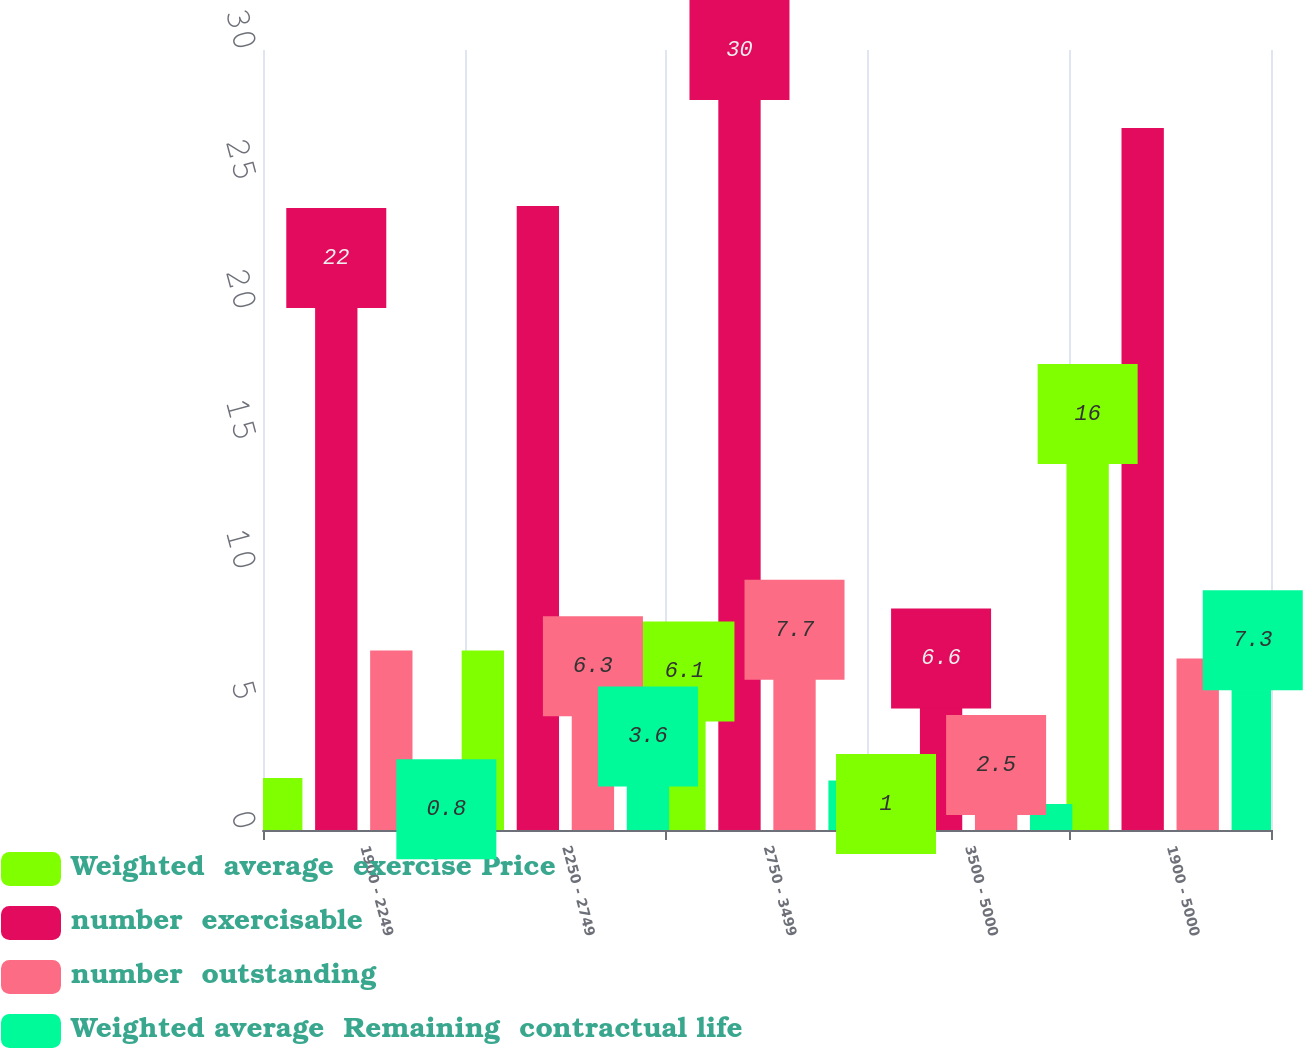Convert chart to OTSL. <chart><loc_0><loc_0><loc_500><loc_500><stacked_bar_chart><ecel><fcel>1900 - 2249<fcel>2250 - 2749<fcel>2750 - 3499<fcel>3500 - 5000<fcel>1900 - 5000<nl><fcel>Weighted  average  exercise Price<fcel>2<fcel>6.9<fcel>6.1<fcel>1<fcel>16<nl><fcel>number  exercisable<fcel>22<fcel>24<fcel>30<fcel>6.6<fcel>27<nl><fcel>number  outstanding<fcel>6.9<fcel>6.3<fcel>7.7<fcel>2.5<fcel>6.6<nl><fcel>Weighted average  Remaining  contractual life<fcel>0.8<fcel>3.6<fcel>1.9<fcel>1<fcel>7.3<nl></chart> 